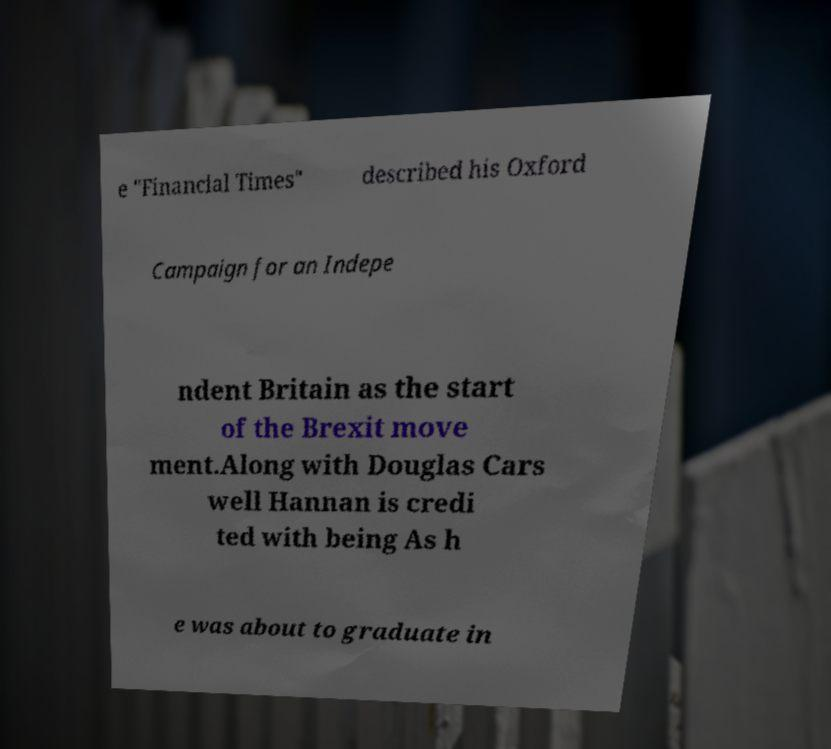What messages or text are displayed in this image? I need them in a readable, typed format. e "Financial Times" described his Oxford Campaign for an Indepe ndent Britain as the start of the Brexit move ment.Along with Douglas Cars well Hannan is credi ted with being As h e was about to graduate in 